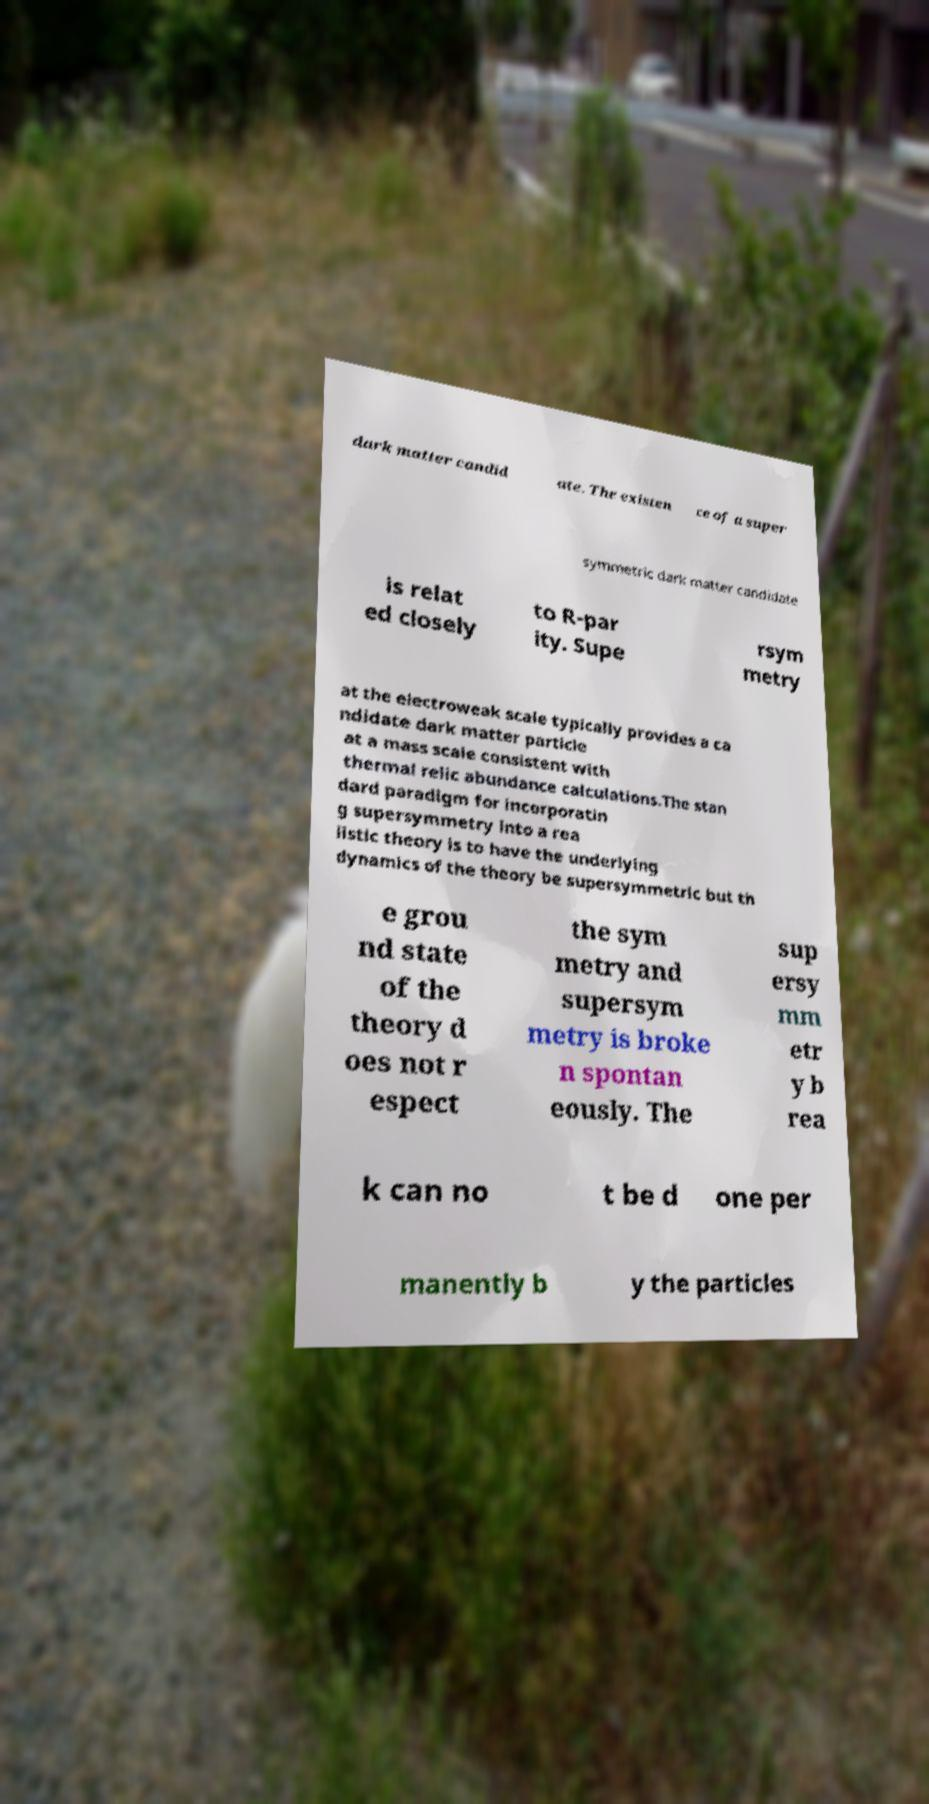Can you accurately transcribe the text from the provided image for me? dark matter candid ate. The existen ce of a super symmetric dark matter candidate is relat ed closely to R-par ity. Supe rsym metry at the electroweak scale typically provides a ca ndidate dark matter particle at a mass scale consistent with thermal relic abundance calculations.The stan dard paradigm for incorporatin g supersymmetry into a rea listic theory is to have the underlying dynamics of the theory be supersymmetric but th e grou nd state of the theory d oes not r espect the sym metry and supersym metry is broke n spontan eously. The sup ersy mm etr y b rea k can no t be d one per manently b y the particles 